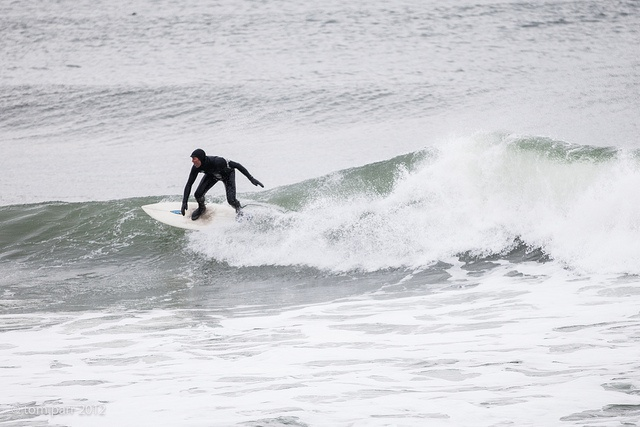Describe the objects in this image and their specific colors. I can see people in lightgray, black, gray, and darkgray tones and surfboard in lightgray, darkgray, and gray tones in this image. 